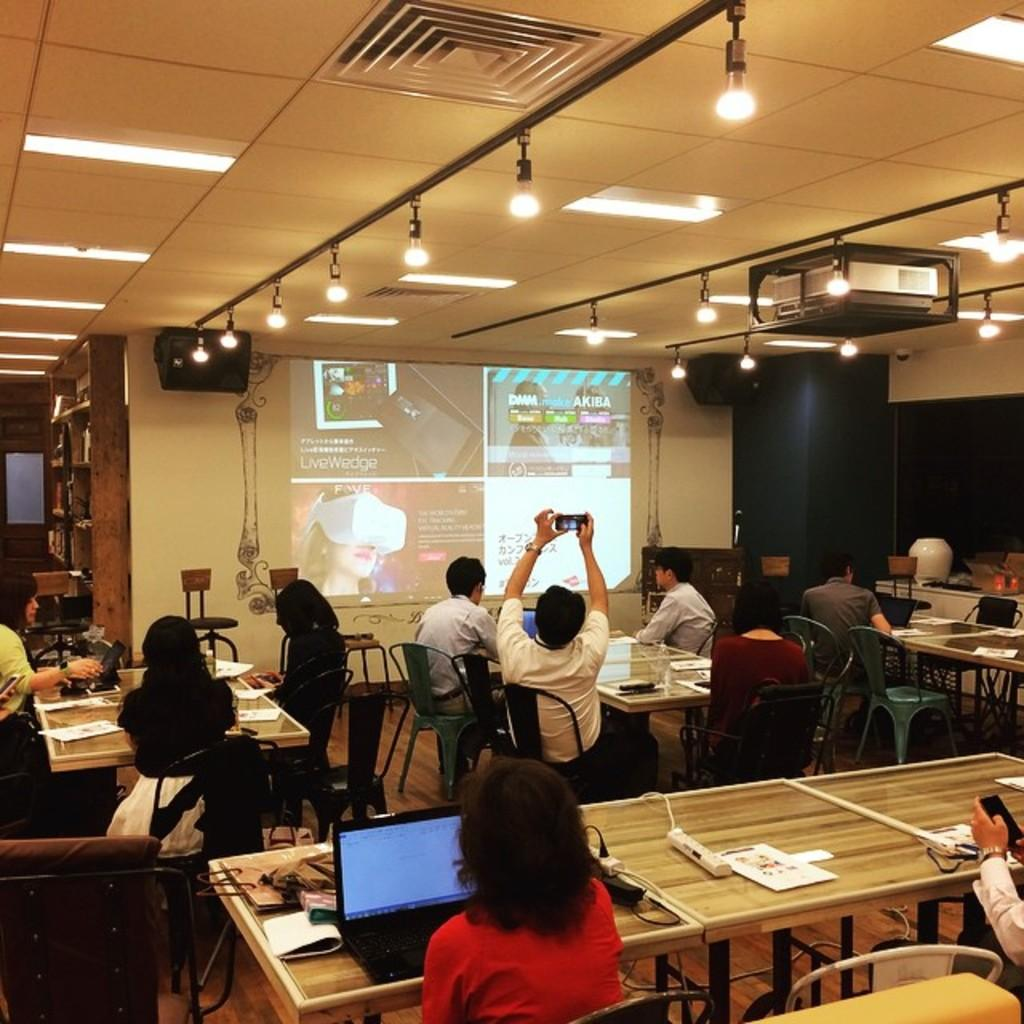What are the people in the image doing? The people in the image are sitting on chairs. Where are the chairs located in relation to the table? The chairs are in front of a table. What can be found on the table? There are things on the table. What is the purpose of the projector screen in the image? The projector screen is likely used for displaying visuals during a presentation or event. What type of lighting is present in the image? There are lights in the image. What devices are used for amplifying sound in the image? There are speakers in the image. What type of carriage can be seen in the image? There is no carriage present in the image. What type of polish is being applied to the table in the image? There is no polish being applied to the table in the image. 